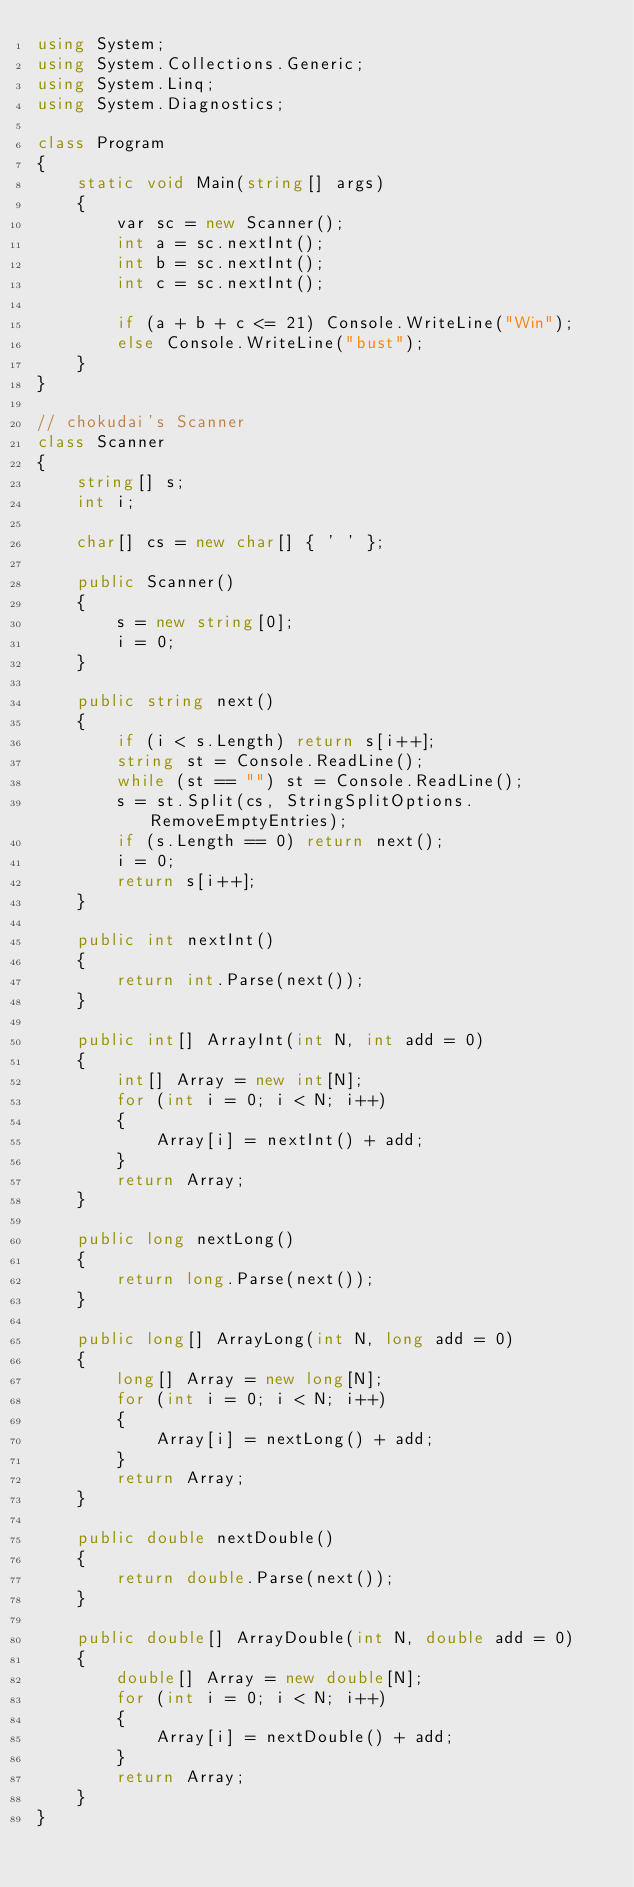<code> <loc_0><loc_0><loc_500><loc_500><_C#_>using System;
using System.Collections.Generic;
using System.Linq;
using System.Diagnostics;

class Program
{
    static void Main(string[] args)
    {
        var sc = new Scanner();
        int a = sc.nextInt();
        int b = sc.nextInt();
        int c = sc.nextInt();

        if (a + b + c <= 21) Console.WriteLine("Win");
        else Console.WriteLine("bust");
    }
}

// chokudai's Scanner
class Scanner
{
    string[] s;
    int i;

    char[] cs = new char[] { ' ' };

    public Scanner()
    {
        s = new string[0];
        i = 0;
    }

    public string next()
    {
        if (i < s.Length) return s[i++];
        string st = Console.ReadLine();
        while (st == "") st = Console.ReadLine();
        s = st.Split(cs, StringSplitOptions.RemoveEmptyEntries);
        if (s.Length == 0) return next();
        i = 0;
        return s[i++];
    }

    public int nextInt()
    {
        return int.Parse(next());
    }

    public int[] ArrayInt(int N, int add = 0)
    {
        int[] Array = new int[N];
        for (int i = 0; i < N; i++)
        {
            Array[i] = nextInt() + add;
        }
        return Array;
    }

    public long nextLong()
    {
        return long.Parse(next());
    }

    public long[] ArrayLong(int N, long add = 0)
    {
        long[] Array = new long[N];
        for (int i = 0; i < N; i++)
        {
            Array[i] = nextLong() + add;
        }
        return Array;
    }

    public double nextDouble()
    {
        return double.Parse(next());
    }

    public double[] ArrayDouble(int N, double add = 0)
    {
        double[] Array = new double[N];
        for (int i = 0; i < N; i++)
        {
            Array[i] = nextDouble() + add;
        }
        return Array;
    }
}
</code> 